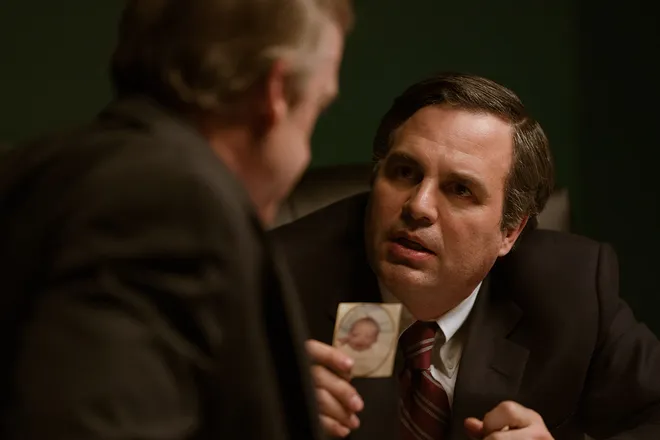What are the key elements in this picture? In this image, actor Mark Ruffalo is portraying the character Rob Bilott from the movie 'Dark Waters'. The scene is set in a dimly lit room with a greenish hue, adding to the tense atmosphere. Mark Ruffalo, dressed in a dark suit and red tie, is leaning forward, apparently engaged in a gripping conversation with another man who is also dressed in a dark suit. The other man holds a photograph and faces Ruffalo's character. The expressions and body language suggest that Ruffalo’s character is making a passionate plea or argument. This setup, along with the specific lighting and composition, adds depth to the scene, reflecting the serious nature of their discussion. 